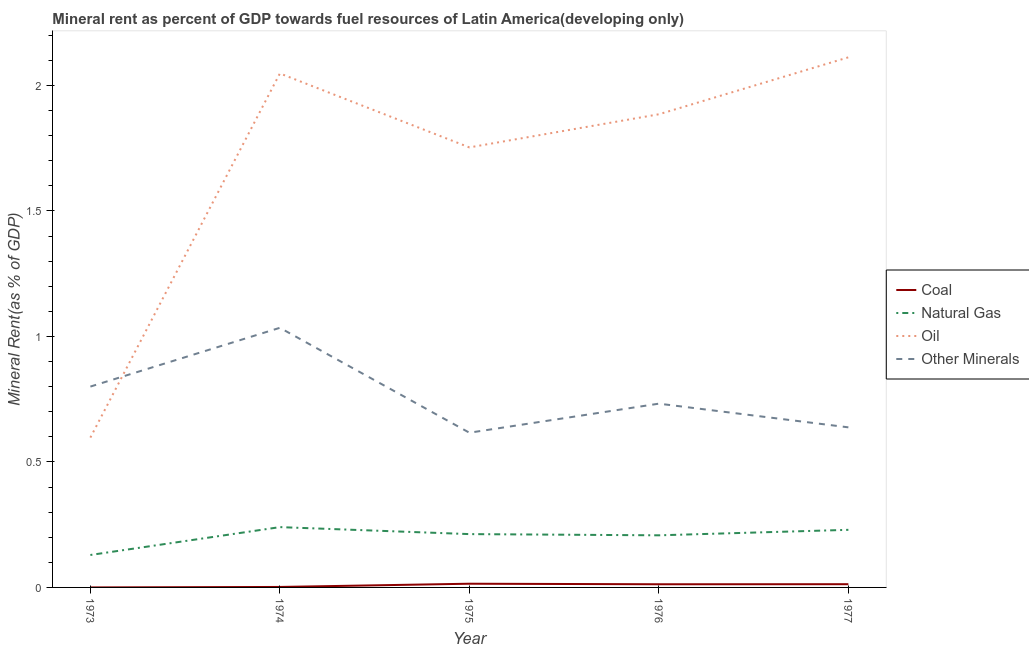How many different coloured lines are there?
Make the answer very short. 4. Is the number of lines equal to the number of legend labels?
Make the answer very short. Yes. What is the oil rent in 1975?
Ensure brevity in your answer.  1.75. Across all years, what is the maximum natural gas rent?
Provide a short and direct response. 0.24. Across all years, what is the minimum coal rent?
Your answer should be very brief. 2.93770621847752e-5. In which year was the oil rent maximum?
Your response must be concise. 1977. What is the total natural gas rent in the graph?
Provide a short and direct response. 1.02. What is the difference between the natural gas rent in 1973 and that in 1975?
Provide a short and direct response. -0.08. What is the difference between the coal rent in 1977 and the  rent of other minerals in 1976?
Provide a short and direct response. -0.72. What is the average natural gas rent per year?
Your answer should be very brief. 0.2. In the year 1974, what is the difference between the natural gas rent and  rent of other minerals?
Offer a very short reply. -0.79. What is the ratio of the natural gas rent in 1973 to that in 1977?
Offer a very short reply. 0.56. Is the difference between the natural gas rent in 1976 and 1977 greater than the difference between the oil rent in 1976 and 1977?
Offer a terse response. Yes. What is the difference between the highest and the second highest oil rent?
Keep it short and to the point. 0.06. What is the difference between the highest and the lowest oil rent?
Give a very brief answer. 1.51. In how many years, is the coal rent greater than the average coal rent taken over all years?
Provide a short and direct response. 3. Is the natural gas rent strictly less than the oil rent over the years?
Give a very brief answer. Yes. How many lines are there?
Offer a terse response. 4. How many years are there in the graph?
Give a very brief answer. 5. Where does the legend appear in the graph?
Ensure brevity in your answer.  Center right. What is the title of the graph?
Ensure brevity in your answer.  Mineral rent as percent of GDP towards fuel resources of Latin America(developing only). Does "Fish species" appear as one of the legend labels in the graph?
Keep it short and to the point. No. What is the label or title of the Y-axis?
Your response must be concise. Mineral Rent(as % of GDP). What is the Mineral Rent(as % of GDP) in Coal in 1973?
Provide a short and direct response. 2.93770621847752e-5. What is the Mineral Rent(as % of GDP) in Natural Gas in 1973?
Your answer should be compact. 0.13. What is the Mineral Rent(as % of GDP) in Oil in 1973?
Your response must be concise. 0.6. What is the Mineral Rent(as % of GDP) of Other Minerals in 1973?
Your response must be concise. 0.8. What is the Mineral Rent(as % of GDP) of Coal in 1974?
Your answer should be very brief. 0. What is the Mineral Rent(as % of GDP) in Natural Gas in 1974?
Keep it short and to the point. 0.24. What is the Mineral Rent(as % of GDP) of Oil in 1974?
Make the answer very short. 2.05. What is the Mineral Rent(as % of GDP) of Other Minerals in 1974?
Offer a terse response. 1.03. What is the Mineral Rent(as % of GDP) of Coal in 1975?
Keep it short and to the point. 0.01. What is the Mineral Rent(as % of GDP) in Natural Gas in 1975?
Provide a succinct answer. 0.21. What is the Mineral Rent(as % of GDP) in Oil in 1975?
Offer a terse response. 1.75. What is the Mineral Rent(as % of GDP) in Other Minerals in 1975?
Your answer should be compact. 0.62. What is the Mineral Rent(as % of GDP) in Coal in 1976?
Ensure brevity in your answer.  0.01. What is the Mineral Rent(as % of GDP) in Natural Gas in 1976?
Provide a short and direct response. 0.21. What is the Mineral Rent(as % of GDP) of Oil in 1976?
Provide a short and direct response. 1.89. What is the Mineral Rent(as % of GDP) in Other Minerals in 1976?
Make the answer very short. 0.73. What is the Mineral Rent(as % of GDP) in Coal in 1977?
Offer a very short reply. 0.01. What is the Mineral Rent(as % of GDP) of Natural Gas in 1977?
Offer a very short reply. 0.23. What is the Mineral Rent(as % of GDP) in Oil in 1977?
Your answer should be very brief. 2.11. What is the Mineral Rent(as % of GDP) in Other Minerals in 1977?
Give a very brief answer. 0.64. Across all years, what is the maximum Mineral Rent(as % of GDP) of Coal?
Keep it short and to the point. 0.01. Across all years, what is the maximum Mineral Rent(as % of GDP) of Natural Gas?
Ensure brevity in your answer.  0.24. Across all years, what is the maximum Mineral Rent(as % of GDP) of Oil?
Give a very brief answer. 2.11. Across all years, what is the maximum Mineral Rent(as % of GDP) in Other Minerals?
Give a very brief answer. 1.03. Across all years, what is the minimum Mineral Rent(as % of GDP) of Coal?
Make the answer very short. 2.93770621847752e-5. Across all years, what is the minimum Mineral Rent(as % of GDP) of Natural Gas?
Provide a short and direct response. 0.13. Across all years, what is the minimum Mineral Rent(as % of GDP) of Oil?
Ensure brevity in your answer.  0.6. Across all years, what is the minimum Mineral Rent(as % of GDP) in Other Minerals?
Offer a terse response. 0.62. What is the total Mineral Rent(as % of GDP) in Coal in the graph?
Provide a succinct answer. 0.04. What is the total Mineral Rent(as % of GDP) of Oil in the graph?
Your answer should be very brief. 8.39. What is the total Mineral Rent(as % of GDP) in Other Minerals in the graph?
Keep it short and to the point. 3.82. What is the difference between the Mineral Rent(as % of GDP) in Coal in 1973 and that in 1974?
Keep it short and to the point. -0. What is the difference between the Mineral Rent(as % of GDP) of Natural Gas in 1973 and that in 1974?
Your answer should be very brief. -0.11. What is the difference between the Mineral Rent(as % of GDP) in Oil in 1973 and that in 1974?
Make the answer very short. -1.45. What is the difference between the Mineral Rent(as % of GDP) of Other Minerals in 1973 and that in 1974?
Offer a very short reply. -0.23. What is the difference between the Mineral Rent(as % of GDP) in Coal in 1973 and that in 1975?
Keep it short and to the point. -0.01. What is the difference between the Mineral Rent(as % of GDP) in Natural Gas in 1973 and that in 1975?
Your response must be concise. -0.08. What is the difference between the Mineral Rent(as % of GDP) of Oil in 1973 and that in 1975?
Your answer should be very brief. -1.16. What is the difference between the Mineral Rent(as % of GDP) of Other Minerals in 1973 and that in 1975?
Offer a very short reply. 0.18. What is the difference between the Mineral Rent(as % of GDP) of Coal in 1973 and that in 1976?
Ensure brevity in your answer.  -0.01. What is the difference between the Mineral Rent(as % of GDP) of Natural Gas in 1973 and that in 1976?
Provide a succinct answer. -0.08. What is the difference between the Mineral Rent(as % of GDP) in Oil in 1973 and that in 1976?
Your answer should be compact. -1.29. What is the difference between the Mineral Rent(as % of GDP) of Other Minerals in 1973 and that in 1976?
Your response must be concise. 0.07. What is the difference between the Mineral Rent(as % of GDP) in Coal in 1973 and that in 1977?
Make the answer very short. -0.01. What is the difference between the Mineral Rent(as % of GDP) in Natural Gas in 1973 and that in 1977?
Offer a terse response. -0.1. What is the difference between the Mineral Rent(as % of GDP) of Oil in 1973 and that in 1977?
Offer a terse response. -1.51. What is the difference between the Mineral Rent(as % of GDP) in Other Minerals in 1973 and that in 1977?
Your response must be concise. 0.16. What is the difference between the Mineral Rent(as % of GDP) in Coal in 1974 and that in 1975?
Offer a very short reply. -0.01. What is the difference between the Mineral Rent(as % of GDP) of Natural Gas in 1974 and that in 1975?
Provide a short and direct response. 0.03. What is the difference between the Mineral Rent(as % of GDP) of Oil in 1974 and that in 1975?
Provide a succinct answer. 0.29. What is the difference between the Mineral Rent(as % of GDP) of Other Minerals in 1974 and that in 1975?
Ensure brevity in your answer.  0.42. What is the difference between the Mineral Rent(as % of GDP) of Coal in 1974 and that in 1976?
Ensure brevity in your answer.  -0.01. What is the difference between the Mineral Rent(as % of GDP) of Natural Gas in 1974 and that in 1976?
Provide a succinct answer. 0.03. What is the difference between the Mineral Rent(as % of GDP) of Oil in 1974 and that in 1976?
Your answer should be compact. 0.16. What is the difference between the Mineral Rent(as % of GDP) of Other Minerals in 1974 and that in 1976?
Ensure brevity in your answer.  0.3. What is the difference between the Mineral Rent(as % of GDP) of Coal in 1974 and that in 1977?
Ensure brevity in your answer.  -0.01. What is the difference between the Mineral Rent(as % of GDP) in Natural Gas in 1974 and that in 1977?
Make the answer very short. 0.01. What is the difference between the Mineral Rent(as % of GDP) in Oil in 1974 and that in 1977?
Your answer should be very brief. -0.06. What is the difference between the Mineral Rent(as % of GDP) in Other Minerals in 1974 and that in 1977?
Your answer should be very brief. 0.4. What is the difference between the Mineral Rent(as % of GDP) of Coal in 1975 and that in 1976?
Offer a terse response. 0. What is the difference between the Mineral Rent(as % of GDP) in Natural Gas in 1975 and that in 1976?
Keep it short and to the point. 0. What is the difference between the Mineral Rent(as % of GDP) in Oil in 1975 and that in 1976?
Your answer should be very brief. -0.13. What is the difference between the Mineral Rent(as % of GDP) in Other Minerals in 1975 and that in 1976?
Give a very brief answer. -0.12. What is the difference between the Mineral Rent(as % of GDP) of Coal in 1975 and that in 1977?
Offer a terse response. 0. What is the difference between the Mineral Rent(as % of GDP) of Natural Gas in 1975 and that in 1977?
Give a very brief answer. -0.02. What is the difference between the Mineral Rent(as % of GDP) in Oil in 1975 and that in 1977?
Offer a very short reply. -0.36. What is the difference between the Mineral Rent(as % of GDP) of Other Minerals in 1975 and that in 1977?
Give a very brief answer. -0.02. What is the difference between the Mineral Rent(as % of GDP) of Coal in 1976 and that in 1977?
Your response must be concise. -0. What is the difference between the Mineral Rent(as % of GDP) of Natural Gas in 1976 and that in 1977?
Give a very brief answer. -0.02. What is the difference between the Mineral Rent(as % of GDP) in Oil in 1976 and that in 1977?
Your response must be concise. -0.23. What is the difference between the Mineral Rent(as % of GDP) in Other Minerals in 1976 and that in 1977?
Offer a very short reply. 0.09. What is the difference between the Mineral Rent(as % of GDP) in Coal in 1973 and the Mineral Rent(as % of GDP) in Natural Gas in 1974?
Your answer should be very brief. -0.24. What is the difference between the Mineral Rent(as % of GDP) of Coal in 1973 and the Mineral Rent(as % of GDP) of Oil in 1974?
Keep it short and to the point. -2.05. What is the difference between the Mineral Rent(as % of GDP) of Coal in 1973 and the Mineral Rent(as % of GDP) of Other Minerals in 1974?
Make the answer very short. -1.03. What is the difference between the Mineral Rent(as % of GDP) in Natural Gas in 1973 and the Mineral Rent(as % of GDP) in Oil in 1974?
Your response must be concise. -1.92. What is the difference between the Mineral Rent(as % of GDP) in Natural Gas in 1973 and the Mineral Rent(as % of GDP) in Other Minerals in 1974?
Your answer should be very brief. -0.91. What is the difference between the Mineral Rent(as % of GDP) in Oil in 1973 and the Mineral Rent(as % of GDP) in Other Minerals in 1974?
Make the answer very short. -0.44. What is the difference between the Mineral Rent(as % of GDP) in Coal in 1973 and the Mineral Rent(as % of GDP) in Natural Gas in 1975?
Provide a short and direct response. -0.21. What is the difference between the Mineral Rent(as % of GDP) of Coal in 1973 and the Mineral Rent(as % of GDP) of Oil in 1975?
Make the answer very short. -1.75. What is the difference between the Mineral Rent(as % of GDP) of Coal in 1973 and the Mineral Rent(as % of GDP) of Other Minerals in 1975?
Offer a very short reply. -0.62. What is the difference between the Mineral Rent(as % of GDP) in Natural Gas in 1973 and the Mineral Rent(as % of GDP) in Oil in 1975?
Ensure brevity in your answer.  -1.62. What is the difference between the Mineral Rent(as % of GDP) of Natural Gas in 1973 and the Mineral Rent(as % of GDP) of Other Minerals in 1975?
Give a very brief answer. -0.49. What is the difference between the Mineral Rent(as % of GDP) in Oil in 1973 and the Mineral Rent(as % of GDP) in Other Minerals in 1975?
Your answer should be very brief. -0.02. What is the difference between the Mineral Rent(as % of GDP) of Coal in 1973 and the Mineral Rent(as % of GDP) of Natural Gas in 1976?
Keep it short and to the point. -0.21. What is the difference between the Mineral Rent(as % of GDP) in Coal in 1973 and the Mineral Rent(as % of GDP) in Oil in 1976?
Give a very brief answer. -1.89. What is the difference between the Mineral Rent(as % of GDP) in Coal in 1973 and the Mineral Rent(as % of GDP) in Other Minerals in 1976?
Your answer should be compact. -0.73. What is the difference between the Mineral Rent(as % of GDP) of Natural Gas in 1973 and the Mineral Rent(as % of GDP) of Oil in 1976?
Your answer should be very brief. -1.76. What is the difference between the Mineral Rent(as % of GDP) of Natural Gas in 1973 and the Mineral Rent(as % of GDP) of Other Minerals in 1976?
Offer a terse response. -0.6. What is the difference between the Mineral Rent(as % of GDP) in Oil in 1973 and the Mineral Rent(as % of GDP) in Other Minerals in 1976?
Your answer should be very brief. -0.14. What is the difference between the Mineral Rent(as % of GDP) in Coal in 1973 and the Mineral Rent(as % of GDP) in Natural Gas in 1977?
Provide a succinct answer. -0.23. What is the difference between the Mineral Rent(as % of GDP) of Coal in 1973 and the Mineral Rent(as % of GDP) of Oil in 1977?
Provide a succinct answer. -2.11. What is the difference between the Mineral Rent(as % of GDP) in Coal in 1973 and the Mineral Rent(as % of GDP) in Other Minerals in 1977?
Your answer should be compact. -0.64. What is the difference between the Mineral Rent(as % of GDP) of Natural Gas in 1973 and the Mineral Rent(as % of GDP) of Oil in 1977?
Make the answer very short. -1.98. What is the difference between the Mineral Rent(as % of GDP) of Natural Gas in 1973 and the Mineral Rent(as % of GDP) of Other Minerals in 1977?
Give a very brief answer. -0.51. What is the difference between the Mineral Rent(as % of GDP) in Oil in 1973 and the Mineral Rent(as % of GDP) in Other Minerals in 1977?
Provide a short and direct response. -0.04. What is the difference between the Mineral Rent(as % of GDP) in Coal in 1974 and the Mineral Rent(as % of GDP) in Natural Gas in 1975?
Keep it short and to the point. -0.21. What is the difference between the Mineral Rent(as % of GDP) in Coal in 1974 and the Mineral Rent(as % of GDP) in Oil in 1975?
Your answer should be compact. -1.75. What is the difference between the Mineral Rent(as % of GDP) in Coal in 1974 and the Mineral Rent(as % of GDP) in Other Minerals in 1975?
Keep it short and to the point. -0.61. What is the difference between the Mineral Rent(as % of GDP) of Natural Gas in 1974 and the Mineral Rent(as % of GDP) of Oil in 1975?
Ensure brevity in your answer.  -1.51. What is the difference between the Mineral Rent(as % of GDP) in Natural Gas in 1974 and the Mineral Rent(as % of GDP) in Other Minerals in 1975?
Offer a very short reply. -0.38. What is the difference between the Mineral Rent(as % of GDP) of Oil in 1974 and the Mineral Rent(as % of GDP) of Other Minerals in 1975?
Offer a terse response. 1.43. What is the difference between the Mineral Rent(as % of GDP) of Coal in 1974 and the Mineral Rent(as % of GDP) of Natural Gas in 1976?
Give a very brief answer. -0.21. What is the difference between the Mineral Rent(as % of GDP) of Coal in 1974 and the Mineral Rent(as % of GDP) of Oil in 1976?
Provide a short and direct response. -1.88. What is the difference between the Mineral Rent(as % of GDP) in Coal in 1974 and the Mineral Rent(as % of GDP) in Other Minerals in 1976?
Give a very brief answer. -0.73. What is the difference between the Mineral Rent(as % of GDP) in Natural Gas in 1974 and the Mineral Rent(as % of GDP) in Oil in 1976?
Make the answer very short. -1.64. What is the difference between the Mineral Rent(as % of GDP) of Natural Gas in 1974 and the Mineral Rent(as % of GDP) of Other Minerals in 1976?
Keep it short and to the point. -0.49. What is the difference between the Mineral Rent(as % of GDP) of Oil in 1974 and the Mineral Rent(as % of GDP) of Other Minerals in 1976?
Provide a short and direct response. 1.32. What is the difference between the Mineral Rent(as % of GDP) of Coal in 1974 and the Mineral Rent(as % of GDP) of Natural Gas in 1977?
Ensure brevity in your answer.  -0.23. What is the difference between the Mineral Rent(as % of GDP) in Coal in 1974 and the Mineral Rent(as % of GDP) in Oil in 1977?
Your answer should be compact. -2.11. What is the difference between the Mineral Rent(as % of GDP) of Coal in 1974 and the Mineral Rent(as % of GDP) of Other Minerals in 1977?
Provide a short and direct response. -0.64. What is the difference between the Mineral Rent(as % of GDP) in Natural Gas in 1974 and the Mineral Rent(as % of GDP) in Oil in 1977?
Offer a very short reply. -1.87. What is the difference between the Mineral Rent(as % of GDP) in Natural Gas in 1974 and the Mineral Rent(as % of GDP) in Other Minerals in 1977?
Provide a succinct answer. -0.4. What is the difference between the Mineral Rent(as % of GDP) in Oil in 1974 and the Mineral Rent(as % of GDP) in Other Minerals in 1977?
Ensure brevity in your answer.  1.41. What is the difference between the Mineral Rent(as % of GDP) in Coal in 1975 and the Mineral Rent(as % of GDP) in Natural Gas in 1976?
Offer a terse response. -0.19. What is the difference between the Mineral Rent(as % of GDP) in Coal in 1975 and the Mineral Rent(as % of GDP) in Oil in 1976?
Give a very brief answer. -1.87. What is the difference between the Mineral Rent(as % of GDP) in Coal in 1975 and the Mineral Rent(as % of GDP) in Other Minerals in 1976?
Offer a terse response. -0.72. What is the difference between the Mineral Rent(as % of GDP) of Natural Gas in 1975 and the Mineral Rent(as % of GDP) of Oil in 1976?
Offer a terse response. -1.67. What is the difference between the Mineral Rent(as % of GDP) in Natural Gas in 1975 and the Mineral Rent(as % of GDP) in Other Minerals in 1976?
Provide a succinct answer. -0.52. What is the difference between the Mineral Rent(as % of GDP) of Oil in 1975 and the Mineral Rent(as % of GDP) of Other Minerals in 1976?
Offer a terse response. 1.02. What is the difference between the Mineral Rent(as % of GDP) of Coal in 1975 and the Mineral Rent(as % of GDP) of Natural Gas in 1977?
Offer a terse response. -0.21. What is the difference between the Mineral Rent(as % of GDP) in Coal in 1975 and the Mineral Rent(as % of GDP) in Oil in 1977?
Offer a very short reply. -2.1. What is the difference between the Mineral Rent(as % of GDP) of Coal in 1975 and the Mineral Rent(as % of GDP) of Other Minerals in 1977?
Your answer should be very brief. -0.62. What is the difference between the Mineral Rent(as % of GDP) of Natural Gas in 1975 and the Mineral Rent(as % of GDP) of Oil in 1977?
Offer a very short reply. -1.9. What is the difference between the Mineral Rent(as % of GDP) of Natural Gas in 1975 and the Mineral Rent(as % of GDP) of Other Minerals in 1977?
Ensure brevity in your answer.  -0.43. What is the difference between the Mineral Rent(as % of GDP) of Oil in 1975 and the Mineral Rent(as % of GDP) of Other Minerals in 1977?
Keep it short and to the point. 1.12. What is the difference between the Mineral Rent(as % of GDP) in Coal in 1976 and the Mineral Rent(as % of GDP) in Natural Gas in 1977?
Ensure brevity in your answer.  -0.22. What is the difference between the Mineral Rent(as % of GDP) of Coal in 1976 and the Mineral Rent(as % of GDP) of Oil in 1977?
Ensure brevity in your answer.  -2.1. What is the difference between the Mineral Rent(as % of GDP) of Coal in 1976 and the Mineral Rent(as % of GDP) of Other Minerals in 1977?
Keep it short and to the point. -0.63. What is the difference between the Mineral Rent(as % of GDP) of Natural Gas in 1976 and the Mineral Rent(as % of GDP) of Oil in 1977?
Provide a succinct answer. -1.9. What is the difference between the Mineral Rent(as % of GDP) of Natural Gas in 1976 and the Mineral Rent(as % of GDP) of Other Minerals in 1977?
Give a very brief answer. -0.43. What is the difference between the Mineral Rent(as % of GDP) of Oil in 1976 and the Mineral Rent(as % of GDP) of Other Minerals in 1977?
Provide a short and direct response. 1.25. What is the average Mineral Rent(as % of GDP) of Coal per year?
Offer a very short reply. 0.01. What is the average Mineral Rent(as % of GDP) of Natural Gas per year?
Your answer should be very brief. 0.2. What is the average Mineral Rent(as % of GDP) of Oil per year?
Offer a terse response. 1.68. What is the average Mineral Rent(as % of GDP) in Other Minerals per year?
Your answer should be compact. 0.76. In the year 1973, what is the difference between the Mineral Rent(as % of GDP) in Coal and Mineral Rent(as % of GDP) in Natural Gas?
Ensure brevity in your answer.  -0.13. In the year 1973, what is the difference between the Mineral Rent(as % of GDP) of Coal and Mineral Rent(as % of GDP) of Oil?
Provide a succinct answer. -0.6. In the year 1973, what is the difference between the Mineral Rent(as % of GDP) in Coal and Mineral Rent(as % of GDP) in Other Minerals?
Offer a very short reply. -0.8. In the year 1973, what is the difference between the Mineral Rent(as % of GDP) of Natural Gas and Mineral Rent(as % of GDP) of Oil?
Your answer should be very brief. -0.47. In the year 1973, what is the difference between the Mineral Rent(as % of GDP) of Natural Gas and Mineral Rent(as % of GDP) of Other Minerals?
Your answer should be compact. -0.67. In the year 1973, what is the difference between the Mineral Rent(as % of GDP) in Oil and Mineral Rent(as % of GDP) in Other Minerals?
Your answer should be compact. -0.2. In the year 1974, what is the difference between the Mineral Rent(as % of GDP) in Coal and Mineral Rent(as % of GDP) in Natural Gas?
Offer a terse response. -0.24. In the year 1974, what is the difference between the Mineral Rent(as % of GDP) in Coal and Mineral Rent(as % of GDP) in Oil?
Keep it short and to the point. -2.05. In the year 1974, what is the difference between the Mineral Rent(as % of GDP) of Coal and Mineral Rent(as % of GDP) of Other Minerals?
Offer a terse response. -1.03. In the year 1974, what is the difference between the Mineral Rent(as % of GDP) in Natural Gas and Mineral Rent(as % of GDP) in Oil?
Your response must be concise. -1.81. In the year 1974, what is the difference between the Mineral Rent(as % of GDP) in Natural Gas and Mineral Rent(as % of GDP) in Other Minerals?
Offer a terse response. -0.79. In the year 1974, what is the difference between the Mineral Rent(as % of GDP) in Oil and Mineral Rent(as % of GDP) in Other Minerals?
Keep it short and to the point. 1.01. In the year 1975, what is the difference between the Mineral Rent(as % of GDP) in Coal and Mineral Rent(as % of GDP) in Natural Gas?
Ensure brevity in your answer.  -0.2. In the year 1975, what is the difference between the Mineral Rent(as % of GDP) of Coal and Mineral Rent(as % of GDP) of Oil?
Ensure brevity in your answer.  -1.74. In the year 1975, what is the difference between the Mineral Rent(as % of GDP) of Coal and Mineral Rent(as % of GDP) of Other Minerals?
Give a very brief answer. -0.6. In the year 1975, what is the difference between the Mineral Rent(as % of GDP) of Natural Gas and Mineral Rent(as % of GDP) of Oil?
Make the answer very short. -1.54. In the year 1975, what is the difference between the Mineral Rent(as % of GDP) of Natural Gas and Mineral Rent(as % of GDP) of Other Minerals?
Your response must be concise. -0.4. In the year 1975, what is the difference between the Mineral Rent(as % of GDP) of Oil and Mineral Rent(as % of GDP) of Other Minerals?
Your answer should be very brief. 1.14. In the year 1976, what is the difference between the Mineral Rent(as % of GDP) of Coal and Mineral Rent(as % of GDP) of Natural Gas?
Your answer should be compact. -0.2. In the year 1976, what is the difference between the Mineral Rent(as % of GDP) in Coal and Mineral Rent(as % of GDP) in Oil?
Offer a terse response. -1.87. In the year 1976, what is the difference between the Mineral Rent(as % of GDP) in Coal and Mineral Rent(as % of GDP) in Other Minerals?
Offer a very short reply. -0.72. In the year 1976, what is the difference between the Mineral Rent(as % of GDP) in Natural Gas and Mineral Rent(as % of GDP) in Oil?
Offer a very short reply. -1.68. In the year 1976, what is the difference between the Mineral Rent(as % of GDP) in Natural Gas and Mineral Rent(as % of GDP) in Other Minerals?
Make the answer very short. -0.52. In the year 1976, what is the difference between the Mineral Rent(as % of GDP) in Oil and Mineral Rent(as % of GDP) in Other Minerals?
Offer a very short reply. 1.15. In the year 1977, what is the difference between the Mineral Rent(as % of GDP) in Coal and Mineral Rent(as % of GDP) in Natural Gas?
Your answer should be compact. -0.22. In the year 1977, what is the difference between the Mineral Rent(as % of GDP) in Coal and Mineral Rent(as % of GDP) in Oil?
Your response must be concise. -2.1. In the year 1977, what is the difference between the Mineral Rent(as % of GDP) in Coal and Mineral Rent(as % of GDP) in Other Minerals?
Make the answer very short. -0.62. In the year 1977, what is the difference between the Mineral Rent(as % of GDP) of Natural Gas and Mineral Rent(as % of GDP) of Oil?
Give a very brief answer. -1.88. In the year 1977, what is the difference between the Mineral Rent(as % of GDP) of Natural Gas and Mineral Rent(as % of GDP) of Other Minerals?
Your answer should be compact. -0.41. In the year 1977, what is the difference between the Mineral Rent(as % of GDP) in Oil and Mineral Rent(as % of GDP) in Other Minerals?
Provide a short and direct response. 1.47. What is the ratio of the Mineral Rent(as % of GDP) of Coal in 1973 to that in 1974?
Your answer should be very brief. 0.02. What is the ratio of the Mineral Rent(as % of GDP) of Natural Gas in 1973 to that in 1974?
Offer a very short reply. 0.54. What is the ratio of the Mineral Rent(as % of GDP) of Oil in 1973 to that in 1974?
Give a very brief answer. 0.29. What is the ratio of the Mineral Rent(as % of GDP) of Other Minerals in 1973 to that in 1974?
Offer a very short reply. 0.77. What is the ratio of the Mineral Rent(as % of GDP) of Coal in 1973 to that in 1975?
Your response must be concise. 0. What is the ratio of the Mineral Rent(as % of GDP) in Natural Gas in 1973 to that in 1975?
Keep it short and to the point. 0.61. What is the ratio of the Mineral Rent(as % of GDP) in Oil in 1973 to that in 1975?
Ensure brevity in your answer.  0.34. What is the ratio of the Mineral Rent(as % of GDP) in Other Minerals in 1973 to that in 1975?
Provide a succinct answer. 1.3. What is the ratio of the Mineral Rent(as % of GDP) in Coal in 1973 to that in 1976?
Ensure brevity in your answer.  0. What is the ratio of the Mineral Rent(as % of GDP) in Natural Gas in 1973 to that in 1976?
Provide a succinct answer. 0.62. What is the ratio of the Mineral Rent(as % of GDP) of Oil in 1973 to that in 1976?
Provide a short and direct response. 0.32. What is the ratio of the Mineral Rent(as % of GDP) in Other Minerals in 1973 to that in 1976?
Offer a terse response. 1.09. What is the ratio of the Mineral Rent(as % of GDP) in Coal in 1973 to that in 1977?
Keep it short and to the point. 0. What is the ratio of the Mineral Rent(as % of GDP) in Natural Gas in 1973 to that in 1977?
Provide a short and direct response. 0.56. What is the ratio of the Mineral Rent(as % of GDP) in Oil in 1973 to that in 1977?
Your answer should be very brief. 0.28. What is the ratio of the Mineral Rent(as % of GDP) in Other Minerals in 1973 to that in 1977?
Make the answer very short. 1.25. What is the ratio of the Mineral Rent(as % of GDP) of Coal in 1974 to that in 1975?
Provide a succinct answer. 0.13. What is the ratio of the Mineral Rent(as % of GDP) in Natural Gas in 1974 to that in 1975?
Ensure brevity in your answer.  1.13. What is the ratio of the Mineral Rent(as % of GDP) in Oil in 1974 to that in 1975?
Your answer should be compact. 1.17. What is the ratio of the Mineral Rent(as % of GDP) of Other Minerals in 1974 to that in 1975?
Make the answer very short. 1.68. What is the ratio of the Mineral Rent(as % of GDP) of Coal in 1974 to that in 1976?
Your response must be concise. 0.15. What is the ratio of the Mineral Rent(as % of GDP) of Natural Gas in 1974 to that in 1976?
Make the answer very short. 1.16. What is the ratio of the Mineral Rent(as % of GDP) in Oil in 1974 to that in 1976?
Make the answer very short. 1.09. What is the ratio of the Mineral Rent(as % of GDP) of Other Minerals in 1974 to that in 1976?
Your answer should be compact. 1.41. What is the ratio of the Mineral Rent(as % of GDP) in Coal in 1974 to that in 1977?
Give a very brief answer. 0.15. What is the ratio of the Mineral Rent(as % of GDP) in Natural Gas in 1974 to that in 1977?
Give a very brief answer. 1.05. What is the ratio of the Mineral Rent(as % of GDP) of Oil in 1974 to that in 1977?
Your answer should be compact. 0.97. What is the ratio of the Mineral Rent(as % of GDP) of Other Minerals in 1974 to that in 1977?
Your answer should be very brief. 1.62. What is the ratio of the Mineral Rent(as % of GDP) in Coal in 1975 to that in 1976?
Provide a short and direct response. 1.18. What is the ratio of the Mineral Rent(as % of GDP) of Natural Gas in 1975 to that in 1976?
Offer a terse response. 1.02. What is the ratio of the Mineral Rent(as % of GDP) in Other Minerals in 1975 to that in 1976?
Provide a short and direct response. 0.84. What is the ratio of the Mineral Rent(as % of GDP) of Coal in 1975 to that in 1977?
Keep it short and to the point. 1.15. What is the ratio of the Mineral Rent(as % of GDP) of Natural Gas in 1975 to that in 1977?
Offer a terse response. 0.93. What is the ratio of the Mineral Rent(as % of GDP) of Oil in 1975 to that in 1977?
Provide a short and direct response. 0.83. What is the ratio of the Mineral Rent(as % of GDP) of Other Minerals in 1975 to that in 1977?
Your response must be concise. 0.97. What is the ratio of the Mineral Rent(as % of GDP) of Coal in 1976 to that in 1977?
Make the answer very short. 0.98. What is the ratio of the Mineral Rent(as % of GDP) in Natural Gas in 1976 to that in 1977?
Give a very brief answer. 0.9. What is the ratio of the Mineral Rent(as % of GDP) in Oil in 1976 to that in 1977?
Give a very brief answer. 0.89. What is the ratio of the Mineral Rent(as % of GDP) of Other Minerals in 1976 to that in 1977?
Your answer should be very brief. 1.15. What is the difference between the highest and the second highest Mineral Rent(as % of GDP) of Coal?
Provide a short and direct response. 0. What is the difference between the highest and the second highest Mineral Rent(as % of GDP) of Natural Gas?
Make the answer very short. 0.01. What is the difference between the highest and the second highest Mineral Rent(as % of GDP) of Oil?
Your response must be concise. 0.06. What is the difference between the highest and the second highest Mineral Rent(as % of GDP) of Other Minerals?
Make the answer very short. 0.23. What is the difference between the highest and the lowest Mineral Rent(as % of GDP) of Coal?
Your answer should be very brief. 0.01. What is the difference between the highest and the lowest Mineral Rent(as % of GDP) of Natural Gas?
Ensure brevity in your answer.  0.11. What is the difference between the highest and the lowest Mineral Rent(as % of GDP) in Oil?
Keep it short and to the point. 1.51. What is the difference between the highest and the lowest Mineral Rent(as % of GDP) in Other Minerals?
Your response must be concise. 0.42. 